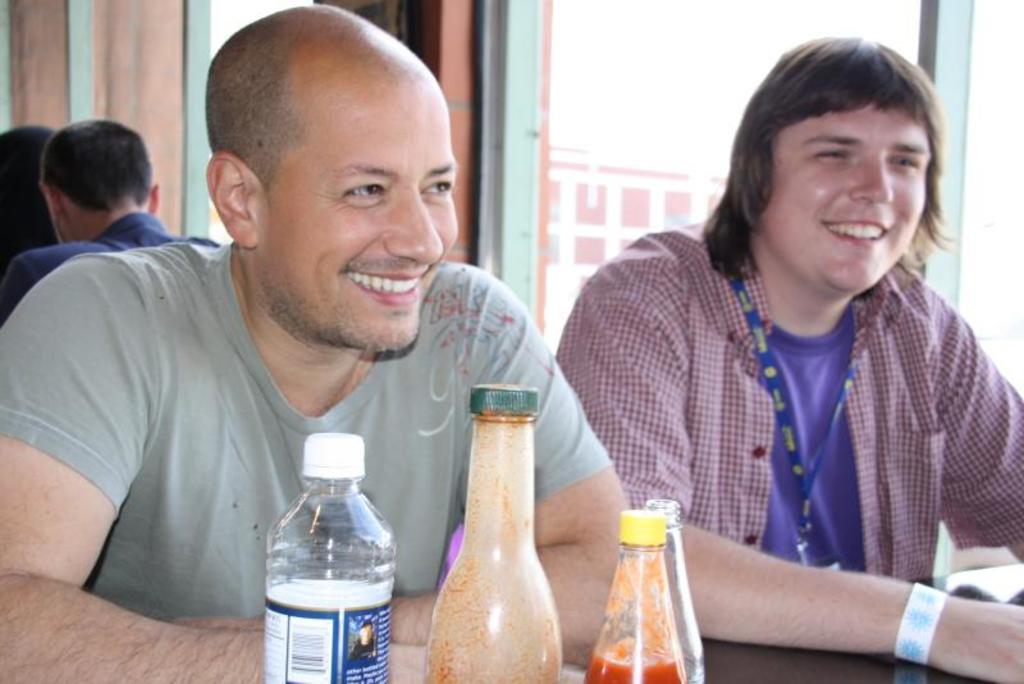How would you summarize this image in a sentence or two? In this picture there are two men sitting, they are smiling. In the foreground there are four bottles. In the background through the glass a building can be seen. To the top left there are two persons seen. In the foreground there is a table. 